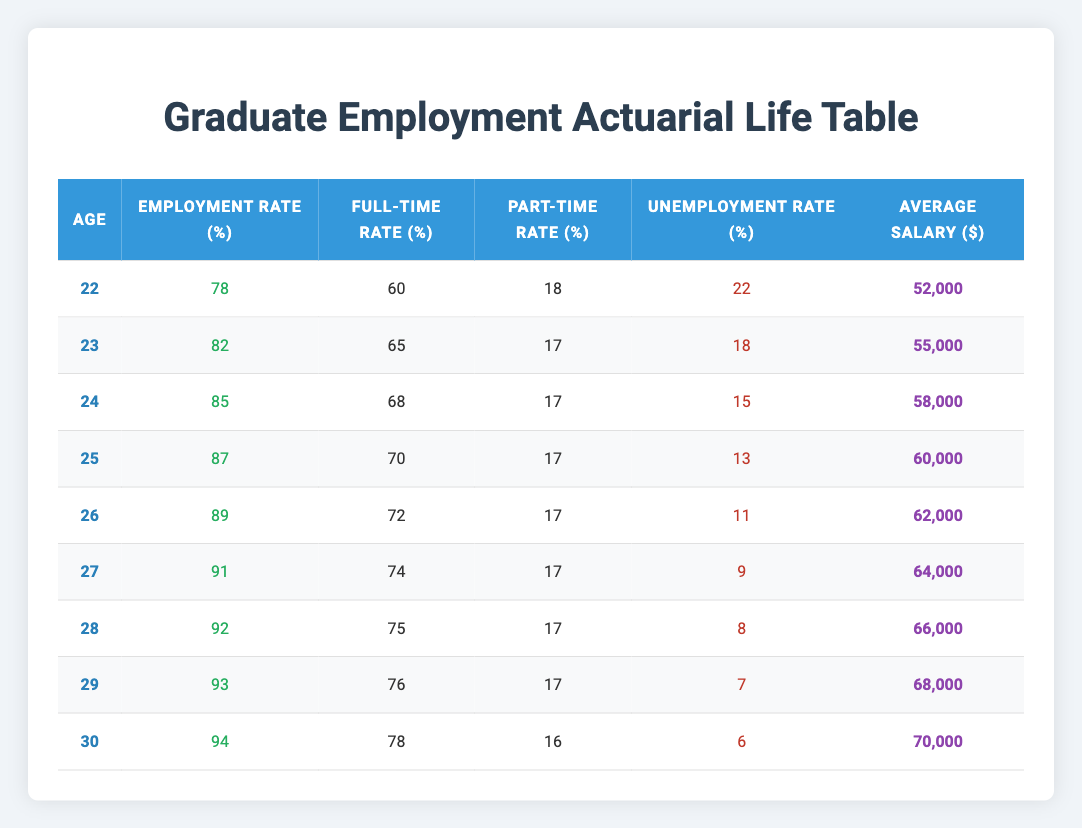What is the employment rate for graduates at age 24? The table shows an employment rate of 85% for graduates who are 24 years old.
Answer: 85% What is the average salary of graduates at age 28? According to the table, the average salary for graduates at age 28 is $66,000.
Answer: 66,000 Is the unemployment rate for graduates at age 27 less than 10%? The table indicates that the unemployment rate at age 27 is 9%, which is indeed less than 10%.
Answer: Yes What is the difference in employment rates between graduates at ages 22 and 30? For age 22, the employment rate is 78%. For age 30, it is 94%. The difference is 94 - 78 = 16%.
Answer: 16% What is the average employment rate for graduates aged 22 to 25? The employment rates for ages 22, 23, 24, and 25 are 78%, 82%, 85%, and 87% respectively. The average is (78 + 82 + 85 + 87) / 4 = 83%.
Answer: 83% Is the full-time employment rate at age 29 higher than the part-time employment rate? The full-time rate for age 29 is 76% and the part-time rate is 17%. Since 76% is higher than 17%, the answer is yes.
Answer: Yes Which age group has the lowest unemployment rate? From the table, age 30 has the lowest unemployment rate of 6%. Other ages have higher rates. Therefore, the answer is age 30.
Answer: 30 How many years does it take for the average salary to increase from age 22 to 30? The average salary at age 22 is $52,000 and at age 30 is $70,000. It takes 8 years to go from age 22 to 30.
Answer: 8 What is the ratio of full-time employment to part-time employment for graduates at age 26? For age 26, the full-time rate is 72% and the part-time rate is 17%. Thus, the ratio is 72:17.
Answer: 72:17 